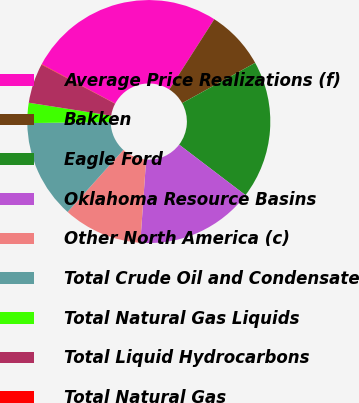Convert chart to OTSL. <chart><loc_0><loc_0><loc_500><loc_500><pie_chart><fcel>Average Price Realizations (f)<fcel>Bakken<fcel>Eagle Ford<fcel>Oklahoma Resource Basins<fcel>Other North America (c)<fcel>Total Crude Oil and Condensate<fcel>Total Natural Gas Liquids<fcel>Total Liquid Hydrocarbons<fcel>Total Natural Gas<nl><fcel>26.23%<fcel>7.91%<fcel>18.38%<fcel>15.76%<fcel>10.53%<fcel>13.15%<fcel>2.68%<fcel>5.29%<fcel>0.06%<nl></chart> 